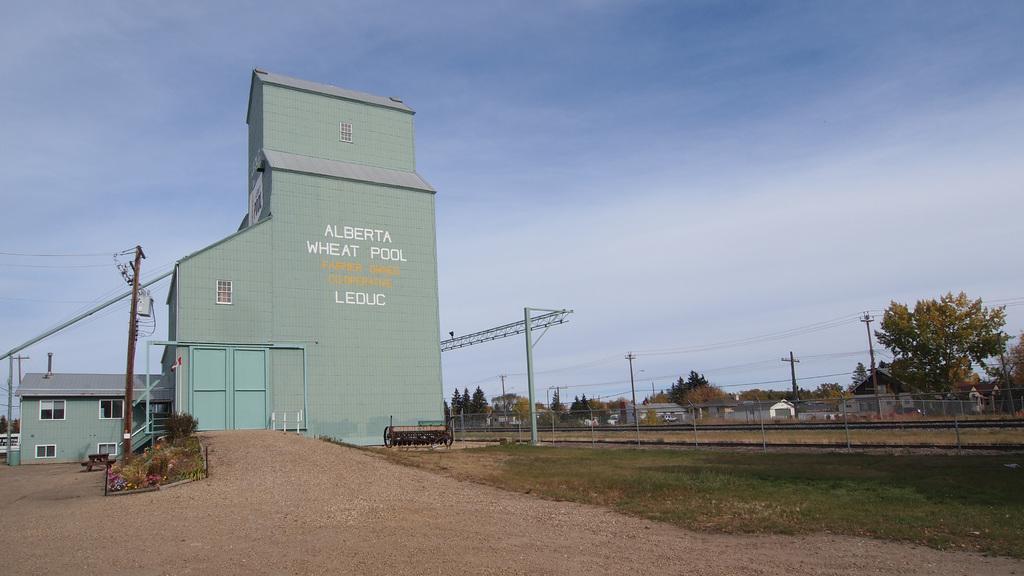Can you describe this image briefly? On the left side, there is a pole having electric lines, there are plants and grass on the ground and there is dry land. On the right side, there's grass on the ground. In the background, there is a building having roof, electric poles which are having electric lines, there are trees and buildings on the ground and there are clouds in the sky. 